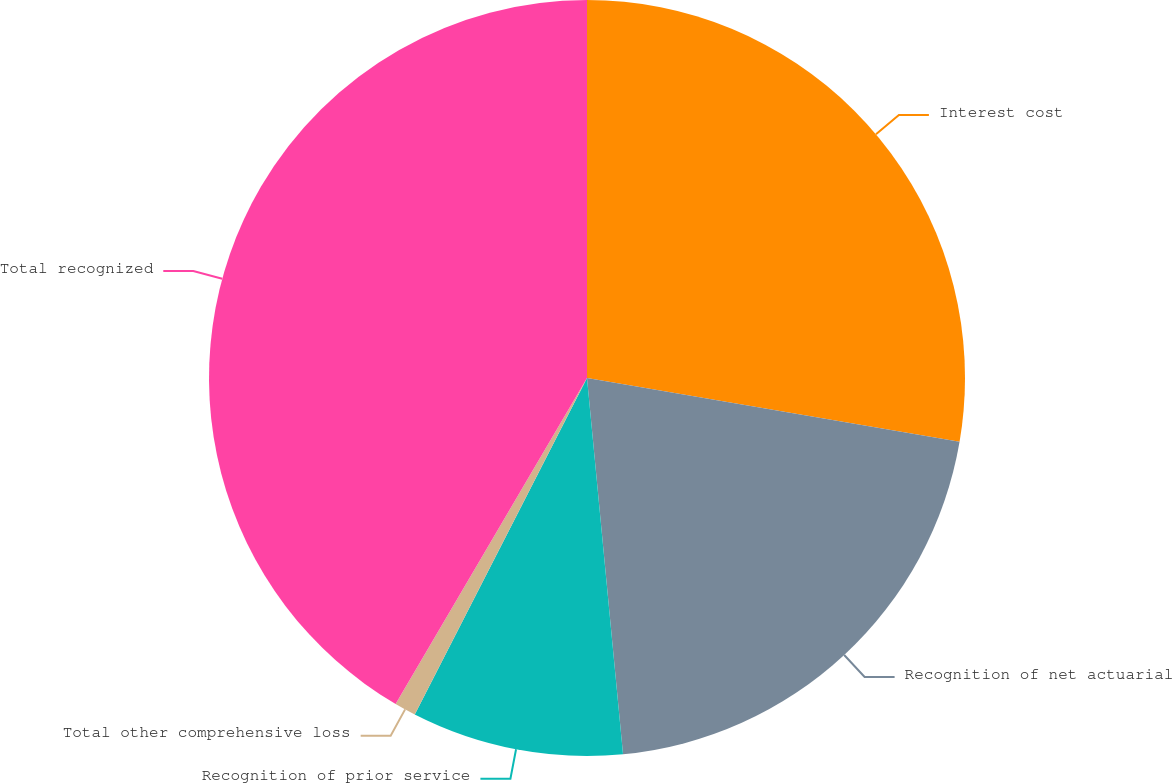Convert chart. <chart><loc_0><loc_0><loc_500><loc_500><pie_chart><fcel>Interest cost<fcel>Recognition of net actuarial<fcel>Recognition of prior service<fcel>Total other comprehensive loss<fcel>Total recognized<nl><fcel>27.7%<fcel>20.78%<fcel>9.05%<fcel>0.92%<fcel>41.55%<nl></chart> 